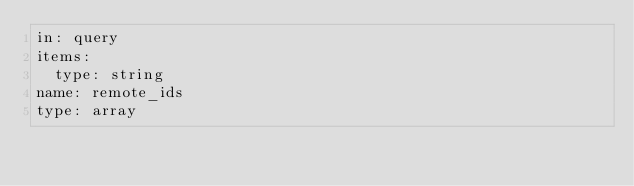<code> <loc_0><loc_0><loc_500><loc_500><_YAML_>in: query
items:
  type: string
name: remote_ids
type: array
</code> 